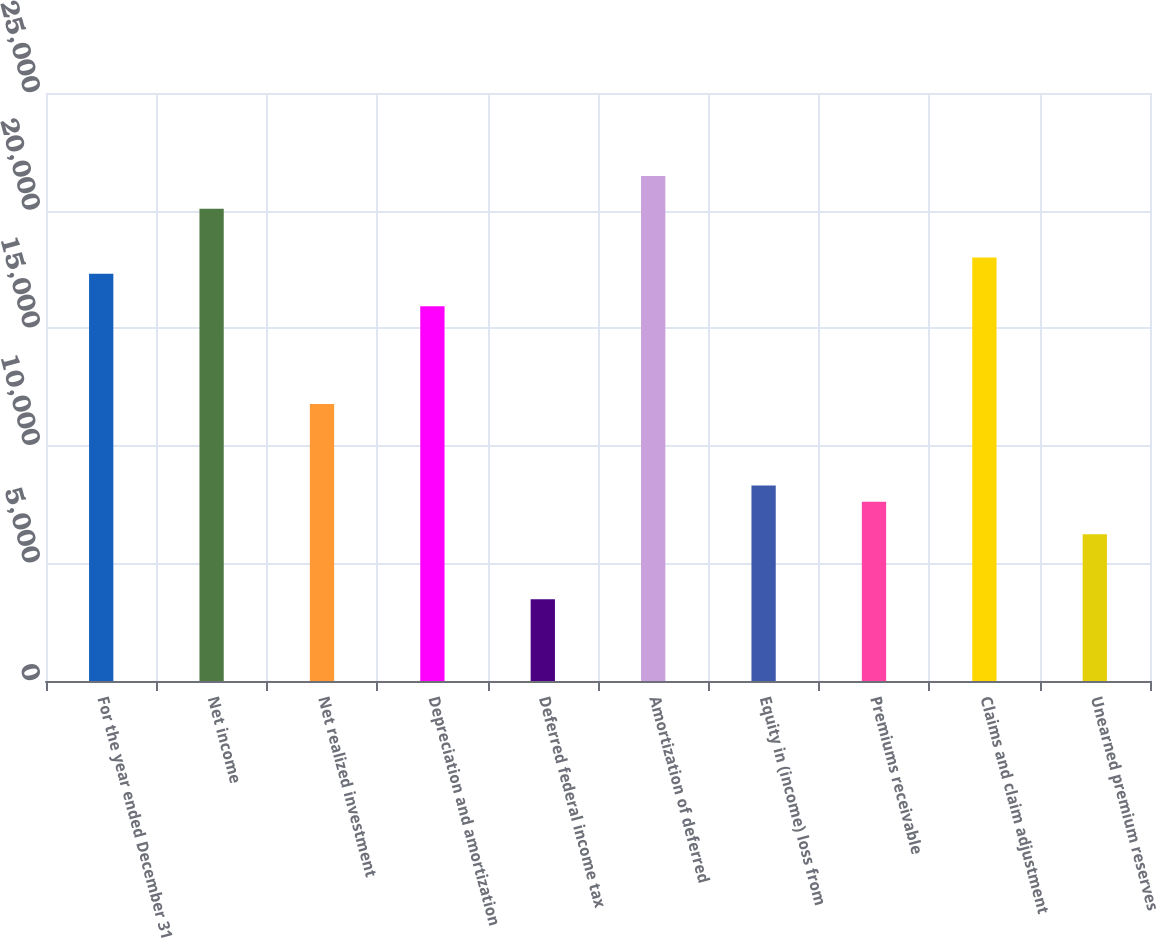<chart> <loc_0><loc_0><loc_500><loc_500><bar_chart><fcel>For the year ended December 31<fcel>Net income<fcel>Net realized investment<fcel>Depreciation and amortization<fcel>Deferred federal income tax<fcel>Amortization of deferred<fcel>Equity in (income) loss from<fcel>Premiums receivable<fcel>Claims and claim adjustment<fcel>Unearned premium reserves<nl><fcel>17315<fcel>20083.8<fcel>11777.4<fcel>15930.6<fcel>3471<fcel>21468.2<fcel>8316.4<fcel>7624.2<fcel>18007.2<fcel>6239.8<nl></chart> 